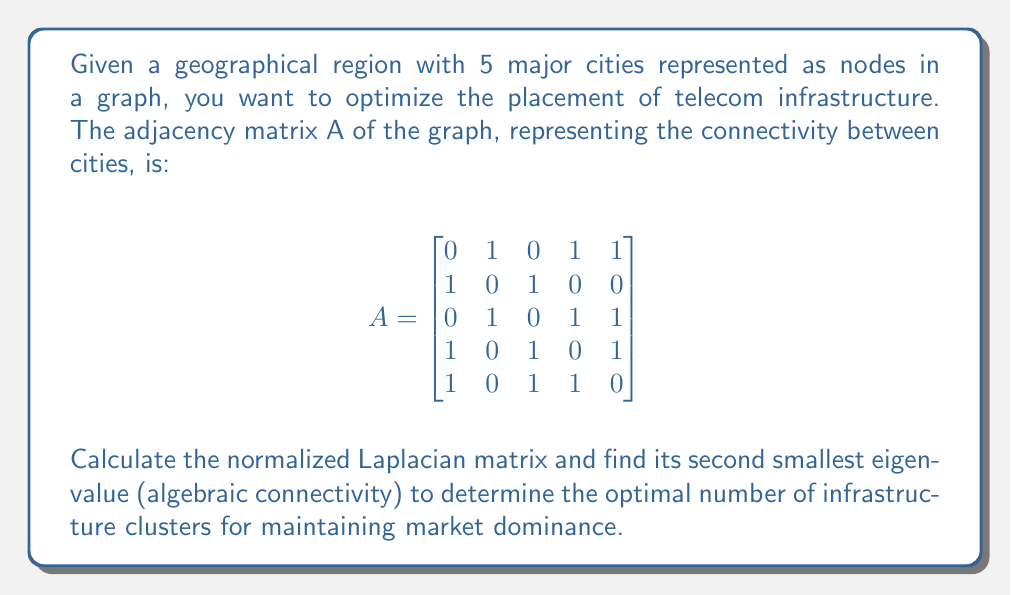Show me your answer to this math problem. Step 1: Calculate the degree matrix D.
The degree of each node is the sum of its row in A:
$$D = \begin{bmatrix}
3 & 0 & 0 & 0 & 0 \\
0 & 2 & 0 & 0 & 0 \\
0 & 0 & 3 & 0 & 0 \\
0 & 0 & 0 & 3 & 0 \\
0 & 0 & 0 & 0 & 3
\end{bmatrix}$$

Step 2: Calculate the normalized Laplacian matrix L.
$$L = I - D^{-1/2}AD^{-1/2}$$

$$D^{-1/2} = \begin{bmatrix}
1/\sqrt{3} & 0 & 0 & 0 & 0 \\
0 & 1/\sqrt{2} & 0 & 0 & 0 \\
0 & 0 & 1/\sqrt{3} & 0 & 0 \\
0 & 0 & 0 & 1/\sqrt{3} & 0 \\
0 & 0 & 0 & 0 & 1/\sqrt{3}
\end{bmatrix}$$

Multiplying out, we get:

$$L = \begin{bmatrix}
1 & -1/\sqrt{6} & 0 & -1/3 & -1/3 \\
-1/\sqrt{6} & 1 & -1/\sqrt{6} & 0 & 0 \\
0 & -1/\sqrt{6} & 1 & -1/3 & -1/3 \\
-1/3 & 0 & -1/3 & 1 & -1/3 \\
-1/3 & 0 & -1/3 & -1/3 & 1
\end{bmatrix}$$

Step 3: Find the eigenvalues of L.
Using a numerical method or symbolic computation, we find the eigenvalues:
$$\lambda_1 = 0, \lambda_2 \approx 0.3820, \lambda_3 \approx 0.8180, \lambda_4 = 1, \lambda_5 \approx 1.8000$$

Step 4: Identify the second smallest eigenvalue (algebraic connectivity).
The second smallest eigenvalue is $\lambda_2 \approx 0.3820$.

Step 5: Interpret the result.
The algebraic connectivity (0.3820) is relatively small, indicating that the graph can be easily divided into two clusters. This suggests that for optimal infrastructure placement and market dominance, the telecom company should consider dividing its operations into two main clusters.
Answer: $\lambda_2 \approx 0.3820$; 2 clusters 